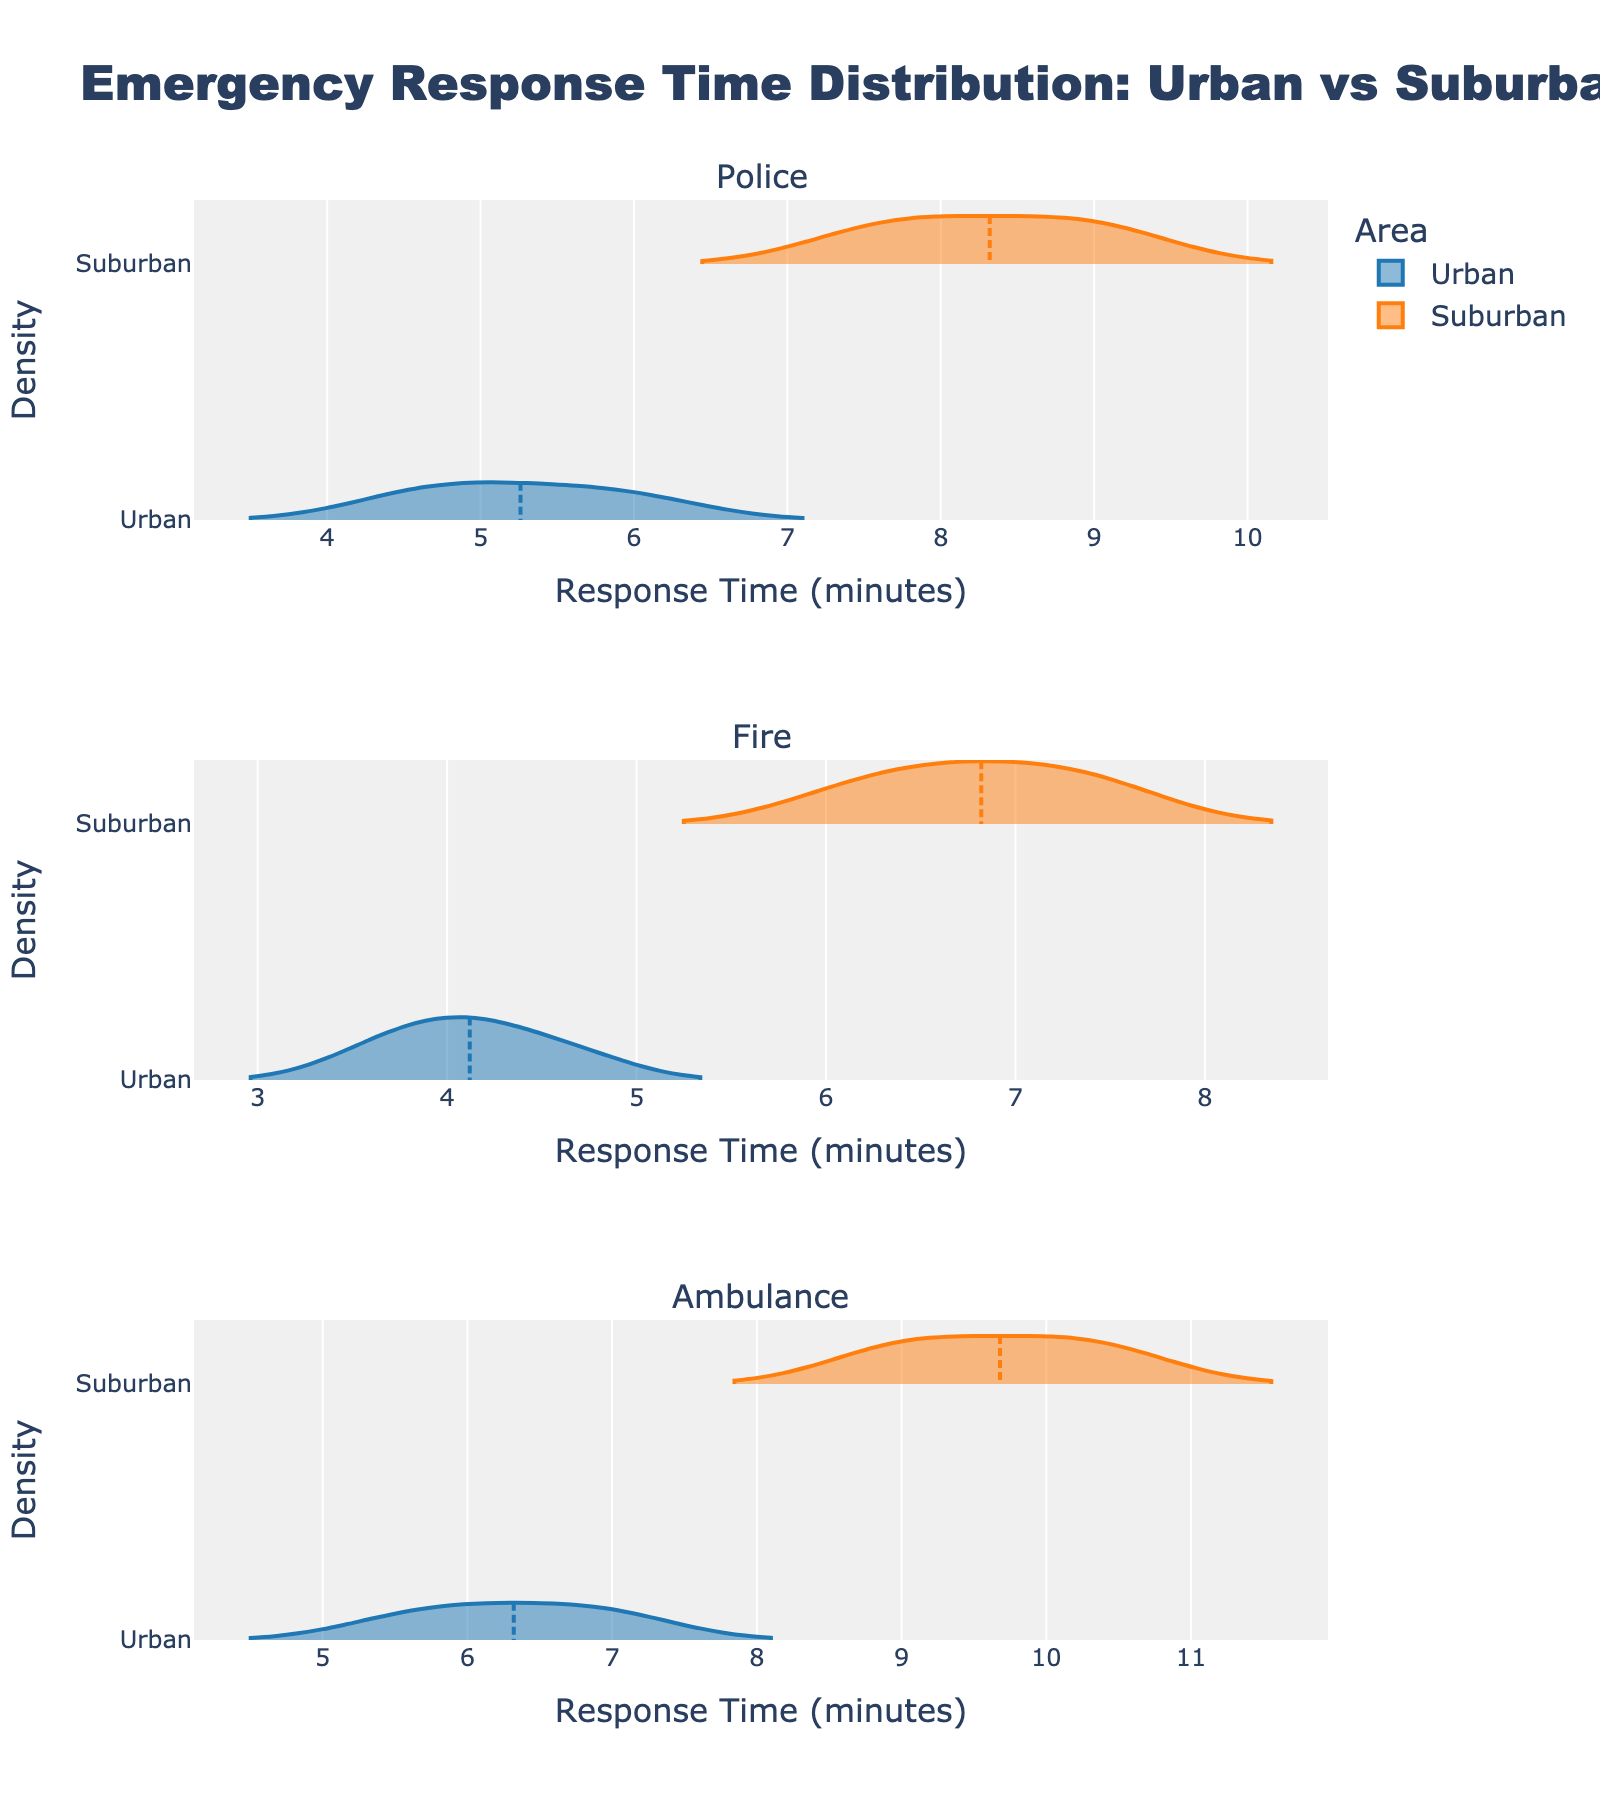What is the title of the plot? The title is located at the top of the figure and indicates what the plot is about. The title is "Emergency Response Time Distribution: Urban vs Suburban."
Answer: Emergency Response Time Distribution: Urban vs Suburban Which emergency service appears in the first subplot? The first subplot is labeled with its respective service type. It represents the "Police" service.
Answer: Police What color represents Urban areas? Colors are used to distinguish between Urban and Suburban areas. Urban areas are represented by a blue color.
Answer: Blue What is the range of response times for Fire services in Suburban areas? By examining the Fire service subplot, the violin plot for Suburban areas spans a specific range of response times. The response times for Fire services in Suburban areas range approximately from 6.1 to 7.5 minutes.
Answer: 6.1 to 7.5 minutes For Ambulance services, which area shows a higher density of response times around 10 minutes? Observing the density plots for Ambulance services, compare the density around the 10-minute mark in Urban and Suburban areas. The suburban area shows a higher density around 10 minutes for Ambulance services.
Answer: Suburban What is the shape of the response time distribution for Police services in Urban areas? The shape of the violin plot describes the distribution. For Urban Police services, the distribution is fairly symmetrical with a concentration around the mean and tails tapering off.
Answer: Symmetrical with central concentration Which emergency service shows the greatest difference in response times between Urban and Suburban areas? By comparing the relative distances between the distributions in all three subplots, the greatest visual difference can be observed. Ambulance services show the greatest difference in response times between Urban and Suburban areas.
Answer: Ambulance Do Suburban areas generally have longer response times than Urban areas for all services? By looking at the position of the plots for each service, compare the entirety of response times for Urban and Suburban areas. In all subplots, response times are longer for Suburban areas than Urban areas.
Answer: Yes How do the mean response times for Fire services compare between Urban and Suburban areas? By looking at the mean line within each violin plot, compare the mean response times for Urban and Suburban Fire services. The mean response time for Suburban Fire services is higher than that for Urban Fire services.
Answer: Suburban is higher 